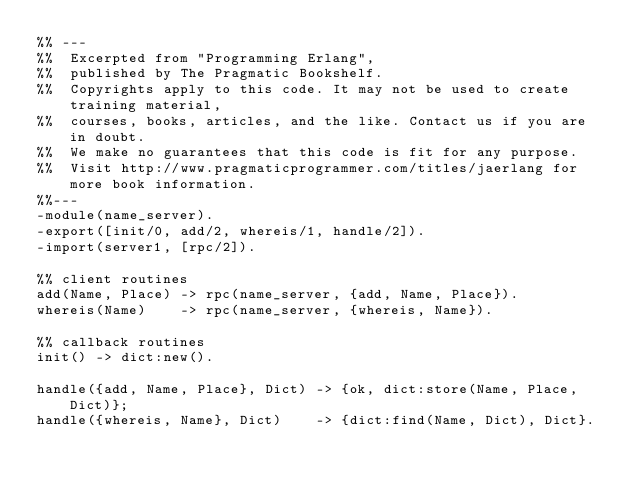<code> <loc_0><loc_0><loc_500><loc_500><_Erlang_>%% ---
%%  Excerpted from "Programming Erlang",
%%  published by The Pragmatic Bookshelf.
%%  Copyrights apply to this code. It may not be used to create training material, 
%%  courses, books, articles, and the like. Contact us if you are in doubt.
%%  We make no guarantees that this code is fit for any purpose. 
%%  Visit http://www.pragmaticprogrammer.com/titles/jaerlang for more book information.
%%---
-module(name_server).
-export([init/0, add/2, whereis/1, handle/2]).
-import(server1, [rpc/2]).

%% client routines
add(Name, Place) -> rpc(name_server, {add, Name, Place}).
whereis(Name)    -> rpc(name_server, {whereis, Name}).

%% callback routines
init() -> dict:new().

handle({add, Name, Place}, Dict) -> {ok, dict:store(Name, Place, Dict)};
handle({whereis, Name}, Dict)    -> {dict:find(Name, Dict), Dict}.
    
</code> 